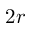Convert formula to latex. <formula><loc_0><loc_0><loc_500><loc_500>2 r</formula> 